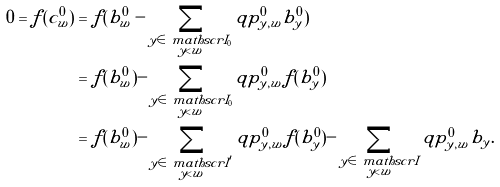Convert formula to latex. <formula><loc_0><loc_0><loc_500><loc_500>0 = f ( c ^ { 0 } _ { w } ) & = f ( b ^ { 0 } _ { w } - \sum _ { \substack { y \in \ m a t h s c r I _ { 0 } \\ y < w } } q p ^ { 0 } _ { y , w } b ^ { 0 } _ { y } ) \\ & = f ( b ^ { 0 } _ { w } ) - \sum _ { \substack { y \in \ m a t h s c r I _ { 0 } \\ y < w } } q p ^ { 0 } _ { y , w } f ( b ^ { 0 } _ { y } ) \\ & = f ( b ^ { 0 } _ { w } ) - \sum _ { \substack { y \in \ m a t h s c r I ^ { \prime } \\ y < w } } q p ^ { 0 } _ { y , w } f ( b ^ { 0 } _ { y } ) - \sum _ { \substack { y \in \ m a t h s c r I \\ y < w } } q p ^ { 0 } _ { y , w } b _ { y } .</formula> 